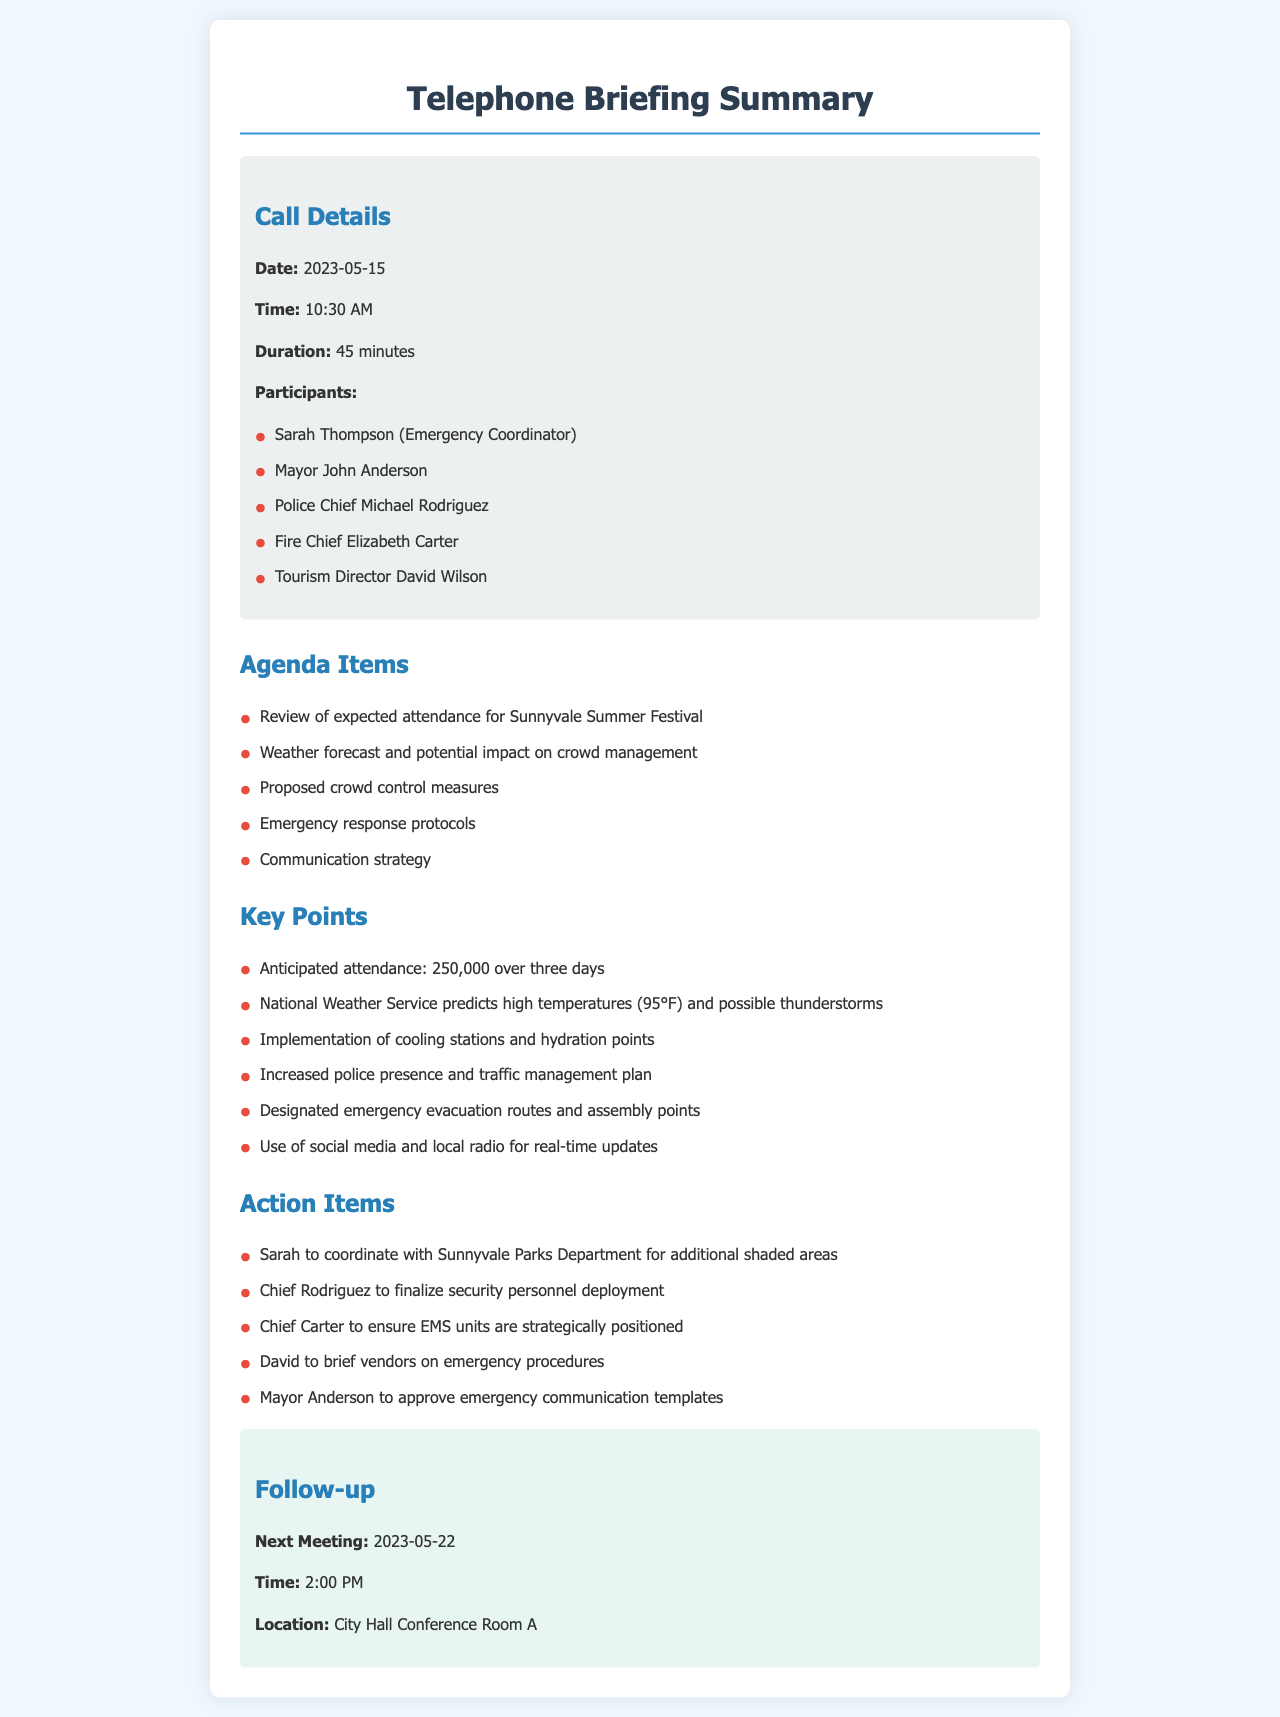What is the date of the call? The date of the call is specified in the document, listed as 2023-05-15.
Answer: 2023-05-15 Who participated as the Emergency Coordinator? The document lists participants, and Sarah Thompson is identified as the Emergency Coordinator.
Answer: Sarah Thompson What is the anticipated attendance for the festival? The document states the anticipated attendance, which is mentioned as 250,000 over three days.
Answer: 250,000 What weather conditions are predicted for the event? The weather forecast is mentioned in the document, predicting high temperatures and possible thunderstorms.
Answer: high temperatures (95°F) and possible thunderstorms What is one of the action items assigned to Chief Carter? The document specifies actions to be taken, and Chief Carter is to ensure EMS units are strategically positioned.
Answer: ensure EMS units are strategically positioned How long did the call last? The duration of the call is provided in the document as 45 minutes.
Answer: 45 minutes What is the next meeting date? The document outlines follow-up information, stating the next meeting date as 2023-05-22.
Answer: 2023-05-22 What communication strategy is discussed in the call? The document mentions the communication strategy focuses on using social media and local radio for updates.
Answer: social media and local radio What location is specified for the next meeting? The document provides details of the next meeting, indicating it will be held in City Hall Conference Room A.
Answer: City Hall Conference Room A 